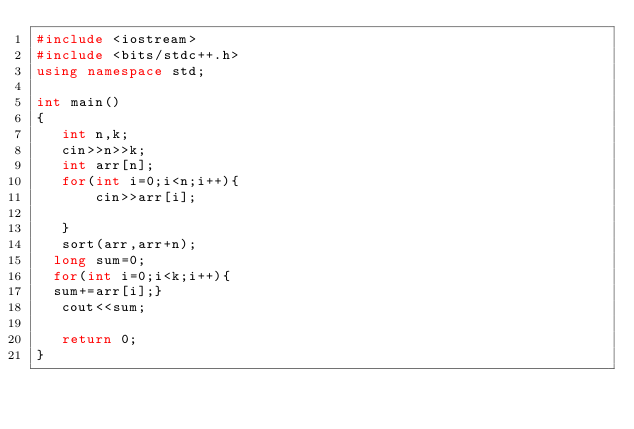Convert code to text. <code><loc_0><loc_0><loc_500><loc_500><_C++_>#include <iostream>
#include <bits/stdc++.h>
using namespace std;

int main()
{
   int n,k;
   cin>>n>>k;
   int arr[n];
   for(int i=0;i<n;i++){
       cin>>arr[i];
       
   }
   sort(arr,arr+n);
  long sum=0;
  for(int i=0;i<k;i++){
  sum+=arr[i];}
   cout<<sum;
   
   return 0;
}</code> 